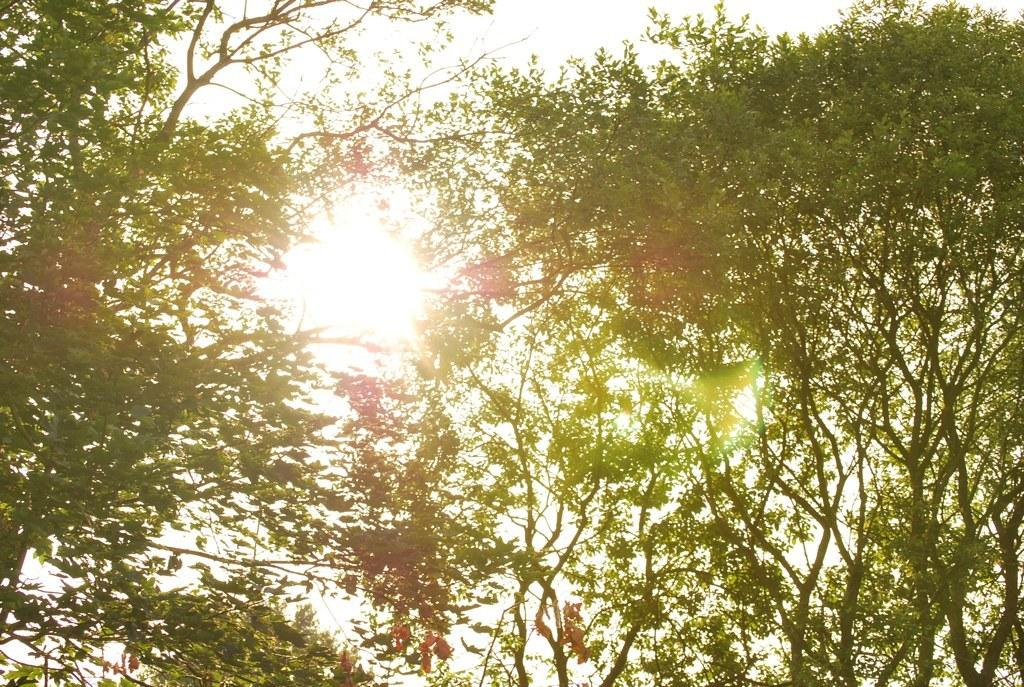What can be seen in the front side of the image? There are tree branches in the front side of the image. What is the main celestial object in the center of the image? A: There is a sun in the center of the image. What type of muscle can be seen flexing in the image? There is no muscle present in the image; it features tree branches and a sun. What kind of cannon is depicted in the image? There is no cannon present in the image. 